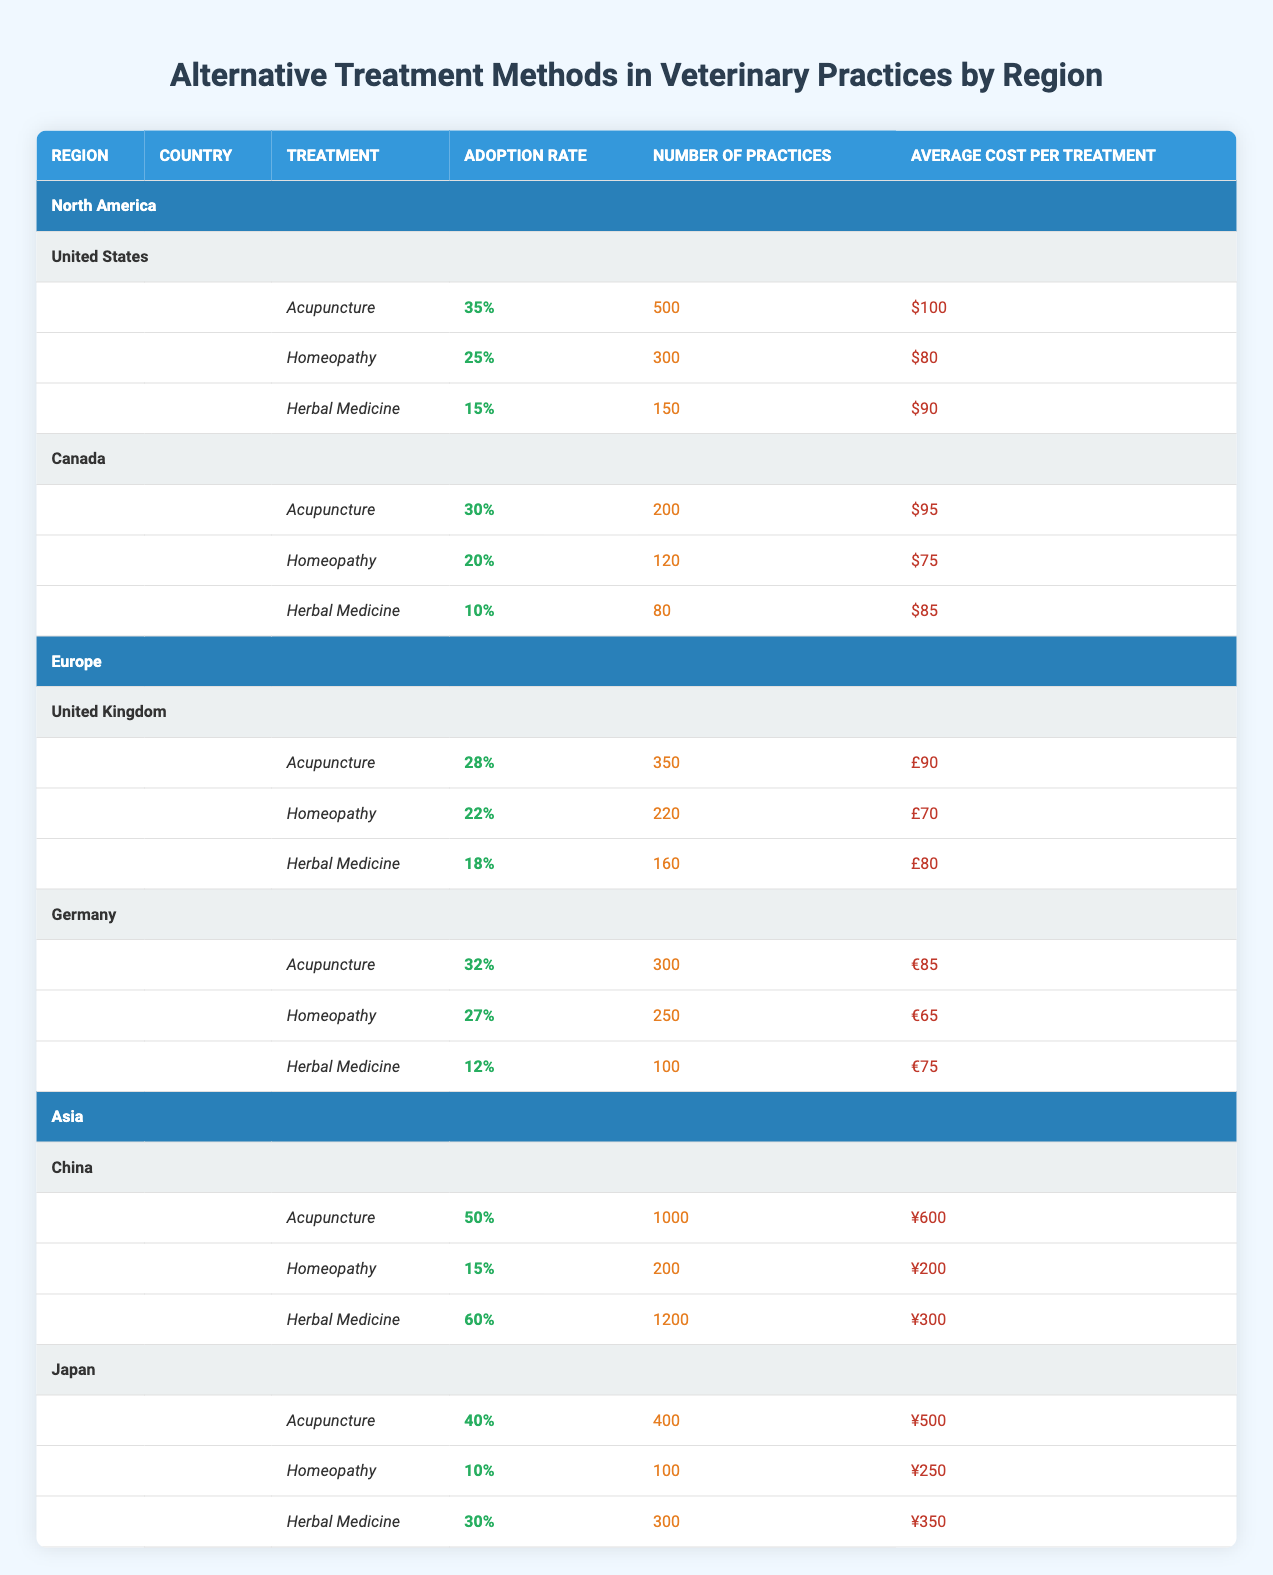What is the adoption rate of acupuncture in the United States? According to the table, the adoption rate of acupuncture in the United States is specifically stated as 35%.
Answer: 35% How many veterinary practices in Canada use homeopathy? The table clearly lists the number of practices using homeopathy in Canada as 120.
Answer: 120 Which treatment method has the highest adoption rate in Asia? From Asia's data in the table, herbal medicine has the highest adoption rate at 60%.
Answer: 60% What is the average cost of herbal medicine treatment in Japan? The table indicates that the average cost of herbal medicine treatment in Japan is ¥350.
Answer: ¥350 True or False: The adoption rate of acupuncture in Germany is higher than that in the United Kingdom. By examining the values, acupuncture's adoption rate in Germany is 32% and in the United Kingdom, it is 28%. Since 32% is greater than 28%, the statement is true.
Answer: True What is the total number of practices using acupuncture across North America? To find the total, add the practices in the United States (500) and Canada (200): 500 + 200 = 700. Therefore, the total number of practices is 700.
Answer: 700 How does the adoption rate of herbal medicine in Canada compare to that in Germany? The adoption rate in Canada is 10% and in Germany, it is 12%. Since 12% is greater than 10%, herbal medicine has a higher adoption rate in Germany.
Answer: Germany has a higher adoption rate What is the median adoption rate for homeopathy across the four countries listed? The adoption rates for homeopathy are as follows: 25% (US), 20% (Canada), 22% (UK), and 27% (Germany). When organized in order (20%, 22%, 25%, 27%), the median rate, which is the average of the two middle values (22% and 25%), is (22 + 25) / 2 = 23.5%.
Answer: 23.5% Which treatment method has the highest average cost in North America? In North America, the average costs for treatments are: Acupuncture $100, Homeopathy $80, and Herbal Medicine $90. The highest among these is acupuncture at $100.
Answer: $100 